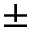<formula> <loc_0><loc_0><loc_500><loc_500>\pm</formula> 